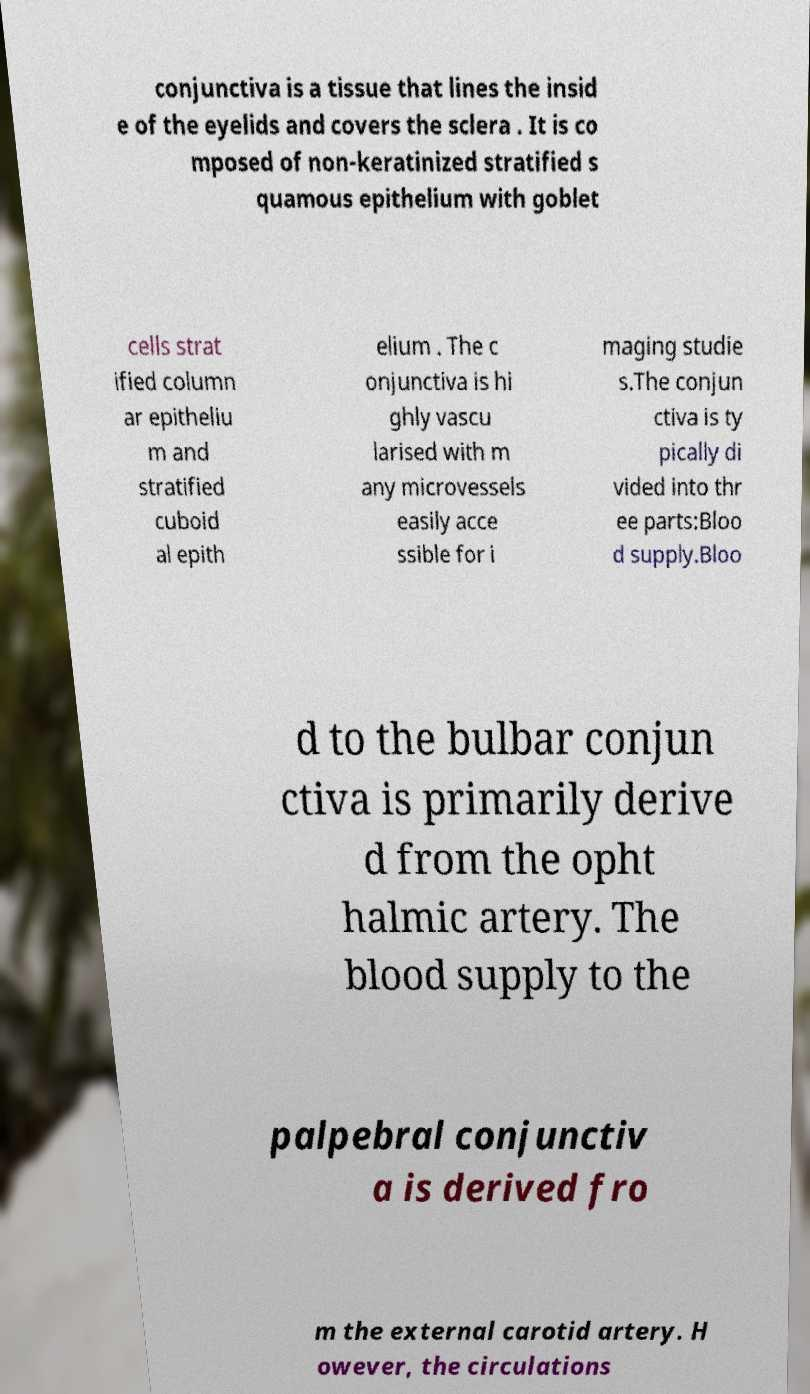I need the written content from this picture converted into text. Can you do that? conjunctiva is a tissue that lines the insid e of the eyelids and covers the sclera . It is co mposed of non-keratinized stratified s quamous epithelium with goblet cells strat ified column ar epitheliu m and stratified cuboid al epith elium . The c onjunctiva is hi ghly vascu larised with m any microvessels easily acce ssible for i maging studie s.The conjun ctiva is ty pically di vided into thr ee parts:Bloo d supply.Bloo d to the bulbar conjun ctiva is primarily derive d from the opht halmic artery. The blood supply to the palpebral conjunctiv a is derived fro m the external carotid artery. H owever, the circulations 